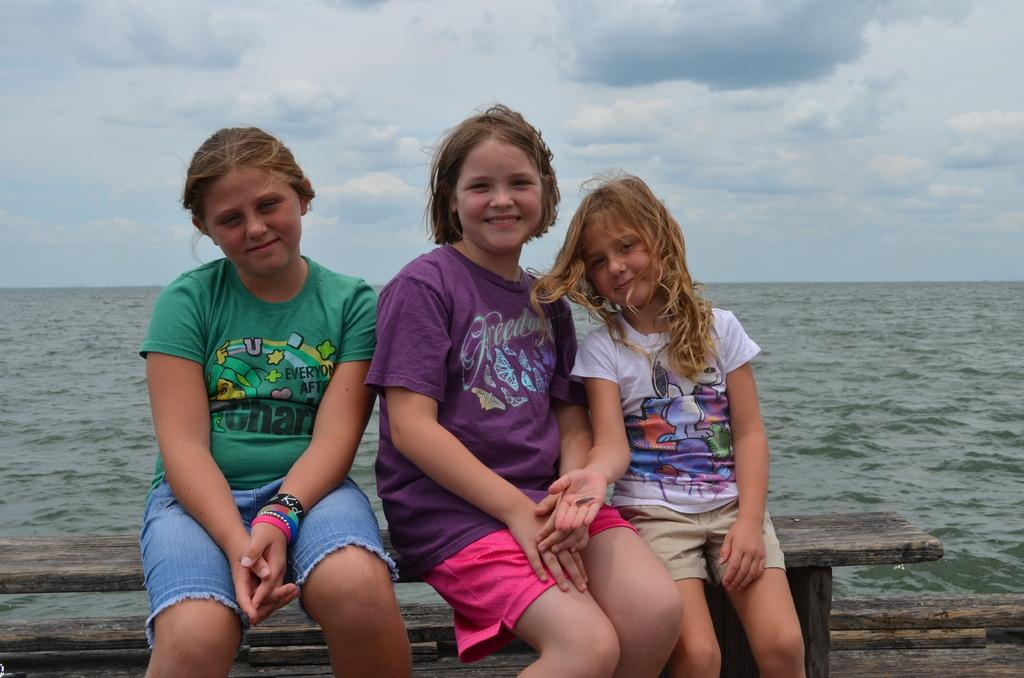How many girls are sitting on the bench in the image? There are three girls sitting on the bench in the image. What is visible behind the bench? There is water visible behind the bench. What can be seen in the sky at the top of the image? There are clouds in the sky at the top of the image. What type of voice can be heard coming from the insect in the image? There is no insect present in the image, so it is not possible to determine what type of voice might be heard. 